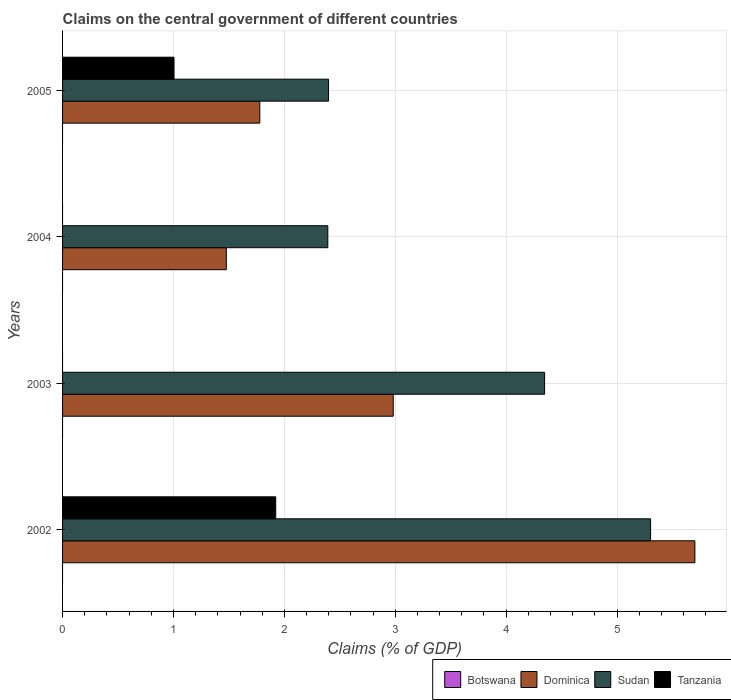How many different coloured bars are there?
Give a very brief answer. 3. How many groups of bars are there?
Your response must be concise. 4. Are the number of bars on each tick of the Y-axis equal?
Provide a short and direct response. No. How many bars are there on the 1st tick from the top?
Ensure brevity in your answer.  3. What is the label of the 3rd group of bars from the top?
Provide a short and direct response. 2003. What is the percentage of GDP claimed on the central government in Tanzania in 2002?
Offer a very short reply. 1.92. Across all years, what is the maximum percentage of GDP claimed on the central government in Sudan?
Your answer should be very brief. 5.3. Across all years, what is the minimum percentage of GDP claimed on the central government in Dominica?
Offer a terse response. 1.48. In which year was the percentage of GDP claimed on the central government in Sudan maximum?
Make the answer very short. 2002. What is the total percentage of GDP claimed on the central government in Tanzania in the graph?
Offer a very short reply. 2.93. What is the difference between the percentage of GDP claimed on the central government in Dominica in 2002 and that in 2003?
Offer a terse response. 2.72. What is the difference between the percentage of GDP claimed on the central government in Tanzania in 2004 and the percentage of GDP claimed on the central government in Sudan in 2002?
Provide a short and direct response. -5.3. What is the average percentage of GDP claimed on the central government in Tanzania per year?
Your answer should be very brief. 0.73. In the year 2003, what is the difference between the percentage of GDP claimed on the central government in Sudan and percentage of GDP claimed on the central government in Dominica?
Provide a short and direct response. 1.36. In how many years, is the percentage of GDP claimed on the central government in Tanzania greater than 3.4 %?
Make the answer very short. 0. What is the ratio of the percentage of GDP claimed on the central government in Dominica in 2004 to that in 2005?
Keep it short and to the point. 0.83. What is the difference between the highest and the second highest percentage of GDP claimed on the central government in Sudan?
Provide a succinct answer. 0.96. What is the difference between the highest and the lowest percentage of GDP claimed on the central government in Dominica?
Offer a terse response. 4.23. Is it the case that in every year, the sum of the percentage of GDP claimed on the central government in Sudan and percentage of GDP claimed on the central government in Tanzania is greater than the sum of percentage of GDP claimed on the central government in Dominica and percentage of GDP claimed on the central government in Botswana?
Your response must be concise. No. Is it the case that in every year, the sum of the percentage of GDP claimed on the central government in Sudan and percentage of GDP claimed on the central government in Botswana is greater than the percentage of GDP claimed on the central government in Tanzania?
Provide a succinct answer. Yes. How many bars are there?
Keep it short and to the point. 10. Are all the bars in the graph horizontal?
Keep it short and to the point. Yes. Does the graph contain any zero values?
Your answer should be very brief. Yes. How many legend labels are there?
Make the answer very short. 4. How are the legend labels stacked?
Give a very brief answer. Horizontal. What is the title of the graph?
Make the answer very short. Claims on the central government of different countries. Does "Japan" appear as one of the legend labels in the graph?
Your answer should be very brief. No. What is the label or title of the X-axis?
Offer a terse response. Claims (% of GDP). What is the Claims (% of GDP) of Dominica in 2002?
Keep it short and to the point. 5.7. What is the Claims (% of GDP) of Sudan in 2002?
Offer a terse response. 5.3. What is the Claims (% of GDP) of Tanzania in 2002?
Offer a very short reply. 1.92. What is the Claims (% of GDP) in Dominica in 2003?
Your answer should be compact. 2.98. What is the Claims (% of GDP) of Sudan in 2003?
Your response must be concise. 4.35. What is the Claims (% of GDP) of Tanzania in 2003?
Provide a short and direct response. 0. What is the Claims (% of GDP) of Botswana in 2004?
Ensure brevity in your answer.  0. What is the Claims (% of GDP) in Dominica in 2004?
Provide a short and direct response. 1.48. What is the Claims (% of GDP) of Sudan in 2004?
Offer a very short reply. 2.39. What is the Claims (% of GDP) in Dominica in 2005?
Give a very brief answer. 1.78. What is the Claims (% of GDP) of Sudan in 2005?
Provide a succinct answer. 2.4. What is the Claims (% of GDP) of Tanzania in 2005?
Keep it short and to the point. 1. Across all years, what is the maximum Claims (% of GDP) of Dominica?
Give a very brief answer. 5.7. Across all years, what is the maximum Claims (% of GDP) in Sudan?
Keep it short and to the point. 5.3. Across all years, what is the maximum Claims (% of GDP) of Tanzania?
Keep it short and to the point. 1.92. Across all years, what is the minimum Claims (% of GDP) of Dominica?
Provide a short and direct response. 1.48. Across all years, what is the minimum Claims (% of GDP) of Sudan?
Ensure brevity in your answer.  2.39. Across all years, what is the minimum Claims (% of GDP) of Tanzania?
Provide a short and direct response. 0. What is the total Claims (% of GDP) of Dominica in the graph?
Give a very brief answer. 11.94. What is the total Claims (% of GDP) in Sudan in the graph?
Ensure brevity in your answer.  14.44. What is the total Claims (% of GDP) in Tanzania in the graph?
Your response must be concise. 2.93. What is the difference between the Claims (% of GDP) of Dominica in 2002 and that in 2003?
Offer a very short reply. 2.72. What is the difference between the Claims (% of GDP) in Sudan in 2002 and that in 2003?
Offer a terse response. 0.96. What is the difference between the Claims (% of GDP) of Dominica in 2002 and that in 2004?
Offer a terse response. 4.23. What is the difference between the Claims (% of GDP) in Sudan in 2002 and that in 2004?
Your answer should be very brief. 2.91. What is the difference between the Claims (% of GDP) of Dominica in 2002 and that in 2005?
Your response must be concise. 3.92. What is the difference between the Claims (% of GDP) of Sudan in 2002 and that in 2005?
Give a very brief answer. 2.9. What is the difference between the Claims (% of GDP) of Tanzania in 2002 and that in 2005?
Ensure brevity in your answer.  0.92. What is the difference between the Claims (% of GDP) of Dominica in 2003 and that in 2004?
Your answer should be very brief. 1.51. What is the difference between the Claims (% of GDP) of Sudan in 2003 and that in 2004?
Your answer should be compact. 1.95. What is the difference between the Claims (% of GDP) in Dominica in 2003 and that in 2005?
Your answer should be very brief. 1.2. What is the difference between the Claims (% of GDP) of Sudan in 2003 and that in 2005?
Your answer should be very brief. 1.95. What is the difference between the Claims (% of GDP) in Dominica in 2004 and that in 2005?
Give a very brief answer. -0.3. What is the difference between the Claims (% of GDP) in Sudan in 2004 and that in 2005?
Ensure brevity in your answer.  -0.01. What is the difference between the Claims (% of GDP) of Dominica in 2002 and the Claims (% of GDP) of Sudan in 2003?
Provide a succinct answer. 1.36. What is the difference between the Claims (% of GDP) in Dominica in 2002 and the Claims (% of GDP) in Sudan in 2004?
Offer a very short reply. 3.31. What is the difference between the Claims (% of GDP) in Dominica in 2002 and the Claims (% of GDP) in Sudan in 2005?
Give a very brief answer. 3.3. What is the difference between the Claims (% of GDP) in Dominica in 2002 and the Claims (% of GDP) in Tanzania in 2005?
Provide a succinct answer. 4.7. What is the difference between the Claims (% of GDP) of Sudan in 2002 and the Claims (% of GDP) of Tanzania in 2005?
Ensure brevity in your answer.  4.3. What is the difference between the Claims (% of GDP) of Dominica in 2003 and the Claims (% of GDP) of Sudan in 2004?
Your response must be concise. 0.59. What is the difference between the Claims (% of GDP) in Dominica in 2003 and the Claims (% of GDP) in Sudan in 2005?
Offer a terse response. 0.58. What is the difference between the Claims (% of GDP) in Dominica in 2003 and the Claims (% of GDP) in Tanzania in 2005?
Your answer should be compact. 1.98. What is the difference between the Claims (% of GDP) of Sudan in 2003 and the Claims (% of GDP) of Tanzania in 2005?
Keep it short and to the point. 3.34. What is the difference between the Claims (% of GDP) of Dominica in 2004 and the Claims (% of GDP) of Sudan in 2005?
Make the answer very short. -0.92. What is the difference between the Claims (% of GDP) of Dominica in 2004 and the Claims (% of GDP) of Tanzania in 2005?
Your answer should be very brief. 0.47. What is the difference between the Claims (% of GDP) in Sudan in 2004 and the Claims (% of GDP) in Tanzania in 2005?
Make the answer very short. 1.39. What is the average Claims (% of GDP) in Botswana per year?
Offer a very short reply. 0. What is the average Claims (% of GDP) in Dominica per year?
Give a very brief answer. 2.98. What is the average Claims (% of GDP) in Sudan per year?
Offer a terse response. 3.61. What is the average Claims (% of GDP) in Tanzania per year?
Make the answer very short. 0.73. In the year 2002, what is the difference between the Claims (% of GDP) in Dominica and Claims (% of GDP) in Sudan?
Provide a short and direct response. 0.4. In the year 2002, what is the difference between the Claims (% of GDP) of Dominica and Claims (% of GDP) of Tanzania?
Your answer should be compact. 3.78. In the year 2002, what is the difference between the Claims (% of GDP) of Sudan and Claims (% of GDP) of Tanzania?
Offer a very short reply. 3.38. In the year 2003, what is the difference between the Claims (% of GDP) in Dominica and Claims (% of GDP) in Sudan?
Offer a terse response. -1.36. In the year 2004, what is the difference between the Claims (% of GDP) of Dominica and Claims (% of GDP) of Sudan?
Provide a succinct answer. -0.92. In the year 2005, what is the difference between the Claims (% of GDP) of Dominica and Claims (% of GDP) of Sudan?
Your answer should be compact. -0.62. In the year 2005, what is the difference between the Claims (% of GDP) in Dominica and Claims (% of GDP) in Tanzania?
Offer a very short reply. 0.77. In the year 2005, what is the difference between the Claims (% of GDP) in Sudan and Claims (% of GDP) in Tanzania?
Offer a terse response. 1.39. What is the ratio of the Claims (% of GDP) in Dominica in 2002 to that in 2003?
Ensure brevity in your answer.  1.91. What is the ratio of the Claims (% of GDP) in Sudan in 2002 to that in 2003?
Offer a terse response. 1.22. What is the ratio of the Claims (% of GDP) of Dominica in 2002 to that in 2004?
Make the answer very short. 3.86. What is the ratio of the Claims (% of GDP) in Sudan in 2002 to that in 2004?
Offer a very short reply. 2.22. What is the ratio of the Claims (% of GDP) of Dominica in 2002 to that in 2005?
Provide a short and direct response. 3.21. What is the ratio of the Claims (% of GDP) in Sudan in 2002 to that in 2005?
Your answer should be compact. 2.21. What is the ratio of the Claims (% of GDP) of Tanzania in 2002 to that in 2005?
Offer a terse response. 1.91. What is the ratio of the Claims (% of GDP) in Dominica in 2003 to that in 2004?
Provide a short and direct response. 2.02. What is the ratio of the Claims (% of GDP) of Sudan in 2003 to that in 2004?
Keep it short and to the point. 1.82. What is the ratio of the Claims (% of GDP) in Dominica in 2003 to that in 2005?
Offer a terse response. 1.68. What is the ratio of the Claims (% of GDP) of Sudan in 2003 to that in 2005?
Offer a very short reply. 1.81. What is the ratio of the Claims (% of GDP) of Dominica in 2004 to that in 2005?
Offer a terse response. 0.83. What is the difference between the highest and the second highest Claims (% of GDP) of Dominica?
Ensure brevity in your answer.  2.72. What is the difference between the highest and the second highest Claims (% of GDP) of Sudan?
Give a very brief answer. 0.96. What is the difference between the highest and the lowest Claims (% of GDP) in Dominica?
Your answer should be very brief. 4.23. What is the difference between the highest and the lowest Claims (% of GDP) in Sudan?
Ensure brevity in your answer.  2.91. What is the difference between the highest and the lowest Claims (% of GDP) of Tanzania?
Your answer should be compact. 1.92. 